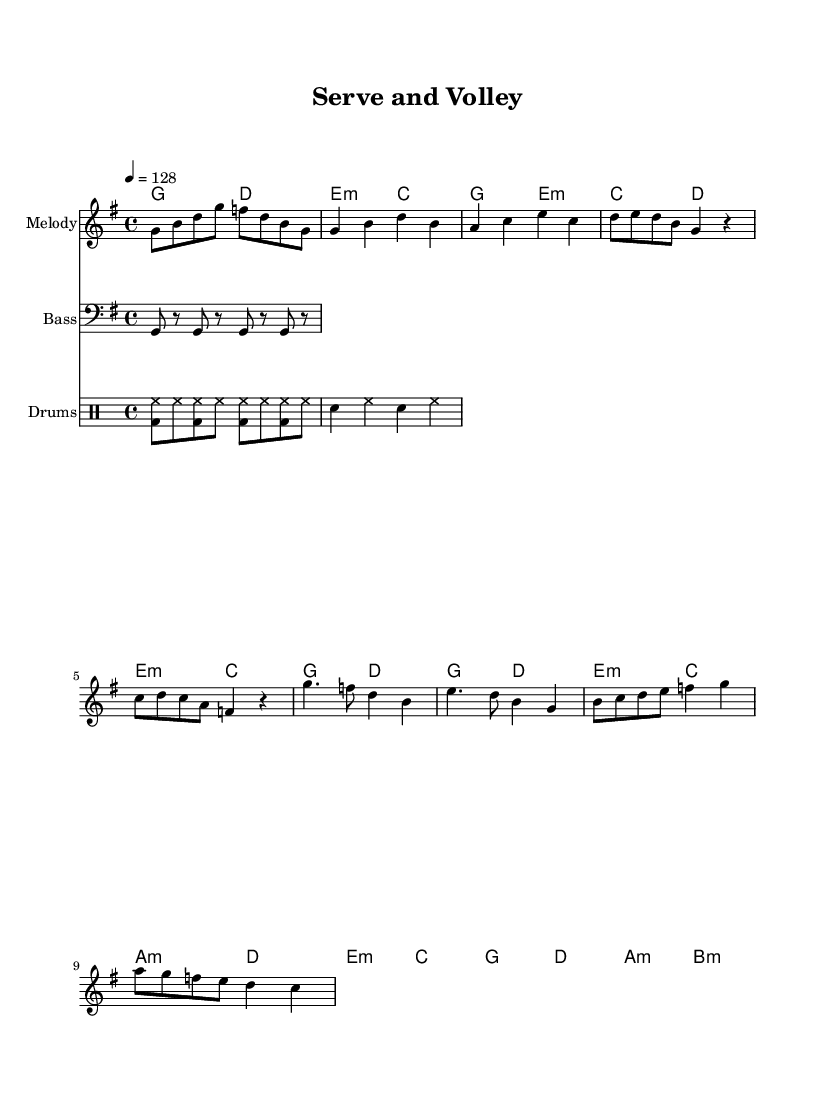What is the key signature of this music? The key signature is G major, which has one sharp (F#). This can be identified by looking at the key signature symbol at the beginning of the staff.
Answer: G major What is the time signature of this music? The time signature is 4/4, indicated at the beginning of the score. It shows that there are four beats in each measure and the quarter note gets one beat.
Answer: 4/4 What is the tempo marking of this music? The tempo marking is 128 beats per minute, specified near the beginning with the notation "4 = 128". This indicates the speed of the music.
Answer: 128 How many measures are in the chorus section? The chorus section consists of four measures, which can be counted by examining the corresponding section of the melody and harmonies labeled as "Chorus".
Answer: 4 What instrument plays the melody part? The melody part is played by the staff labeled "Melody." This indicates that the primary melodic lines are designated for this part.
Answer: Melody How many different chords are used throughout the music? There are seven different chords identified from the harmonies section as follows: G, D, E minor, C, A minor, B minor. Each chord can be counted from the chord symbols listed.
Answer: 7 Which section includes tennis-inspired choreography? The chorus section likely includes tennis-inspired choreography, as it typically contains a more dynamic and energetic rhythm, which would complement such movements.
Answer: Chorus 